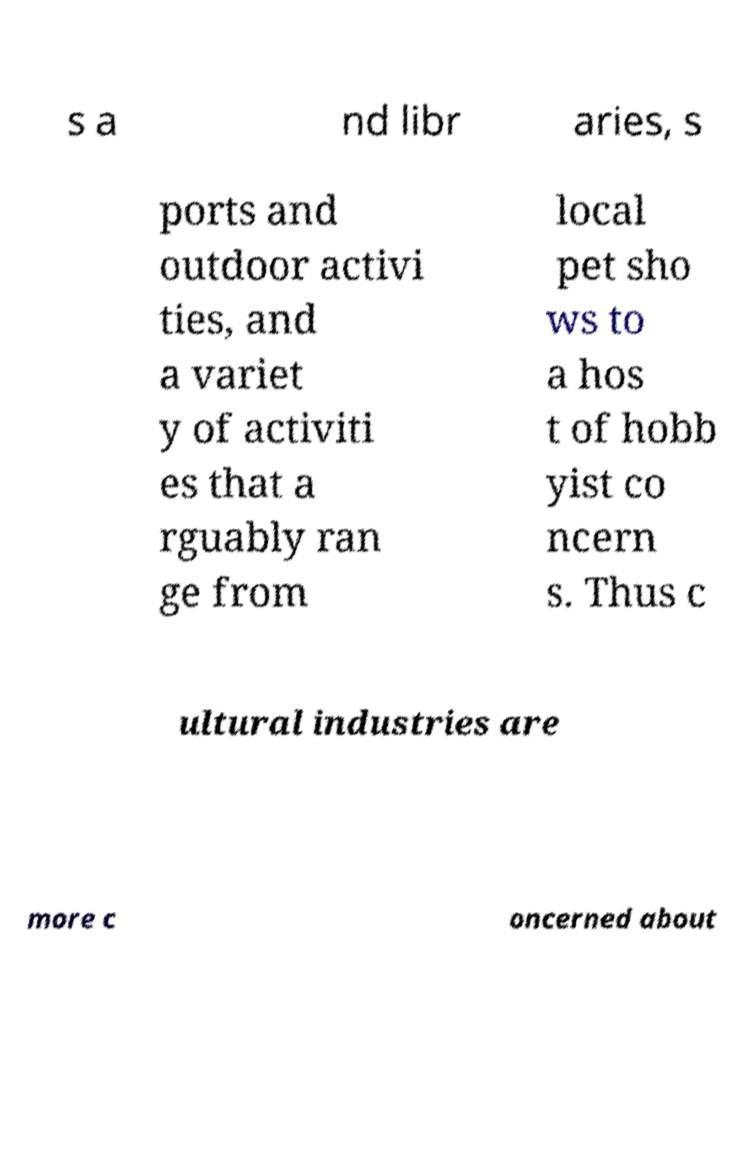Could you extract and type out the text from this image? s a nd libr aries, s ports and outdoor activi ties, and a variet y of activiti es that a rguably ran ge from local pet sho ws to a hos t of hobb yist co ncern s. Thus c ultural industries are more c oncerned about 